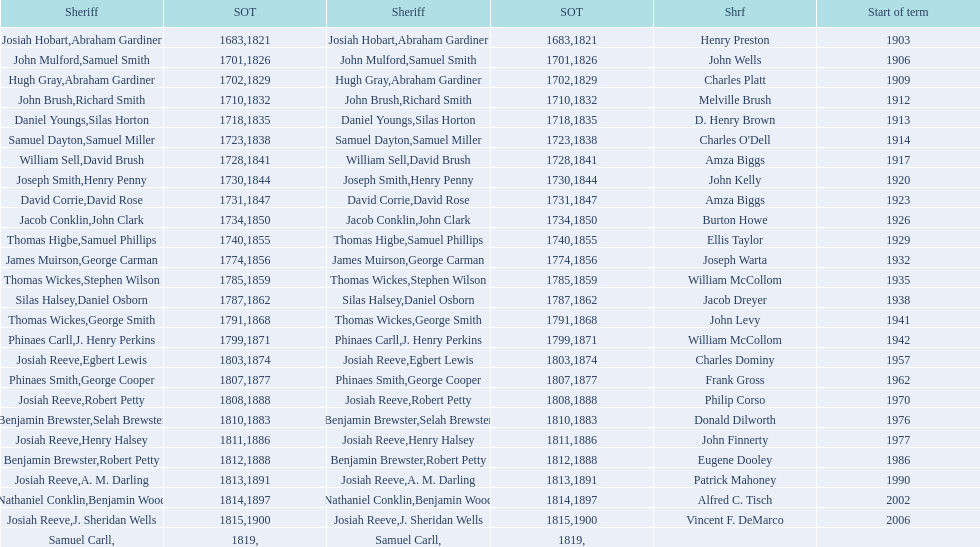What is the total number of sheriffs that were in office in suffolk county between 1903 and 1957? 17. 